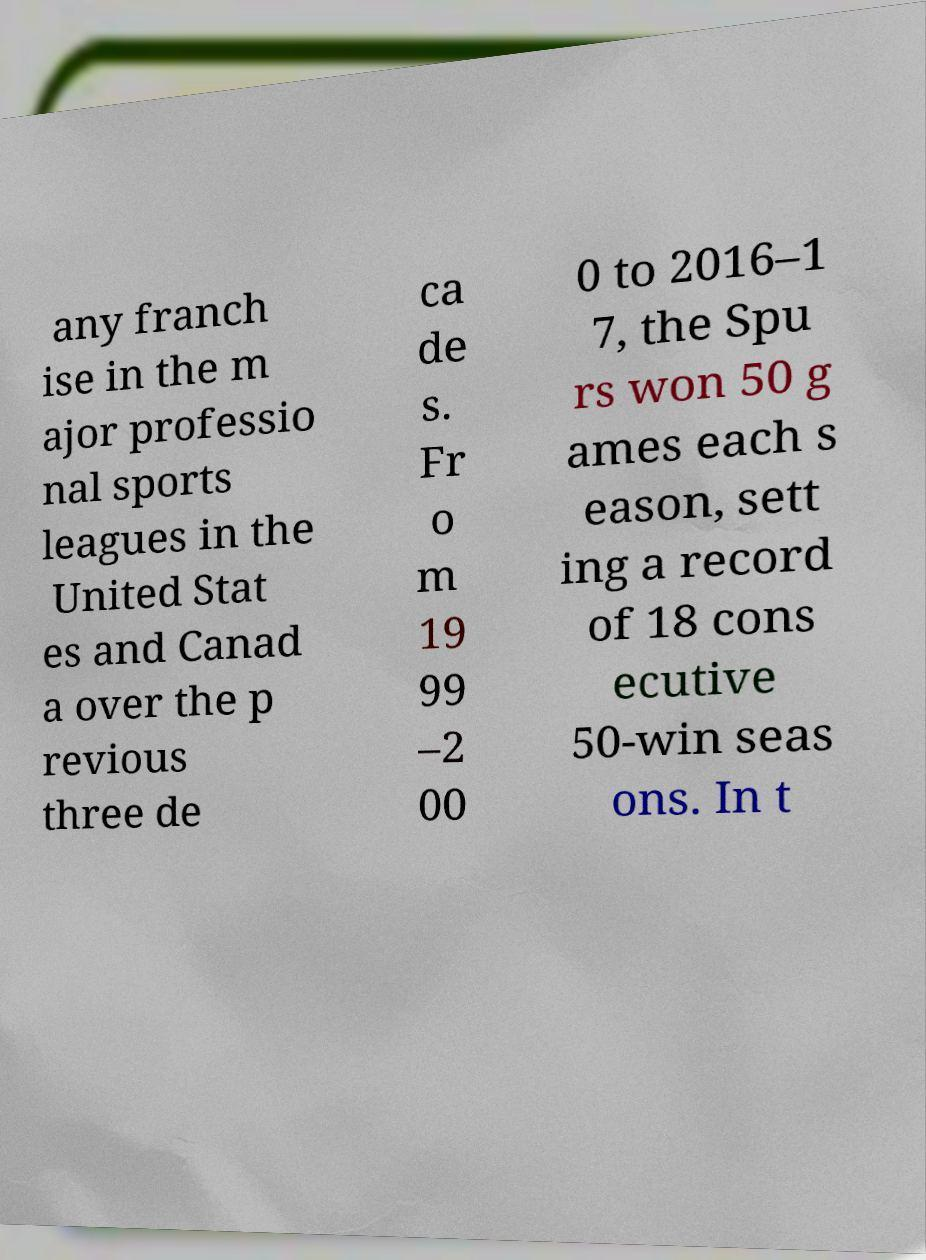For documentation purposes, I need the text within this image transcribed. Could you provide that? any franch ise in the m ajor professio nal sports leagues in the United Stat es and Canad a over the p revious three de ca de s. Fr o m 19 99 –2 00 0 to 2016–1 7, the Spu rs won 50 g ames each s eason, sett ing a record of 18 cons ecutive 50-win seas ons. In t 